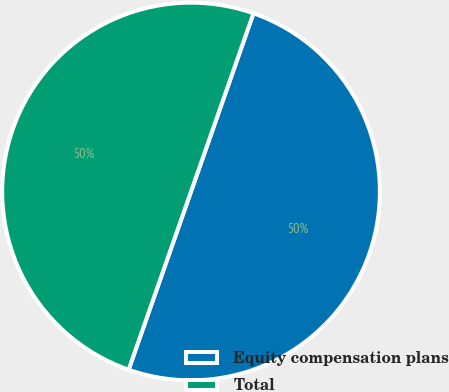<chart> <loc_0><loc_0><loc_500><loc_500><pie_chart><fcel>Equity compensation plans<fcel>Total<nl><fcel>50.0%<fcel>50.0%<nl></chart> 